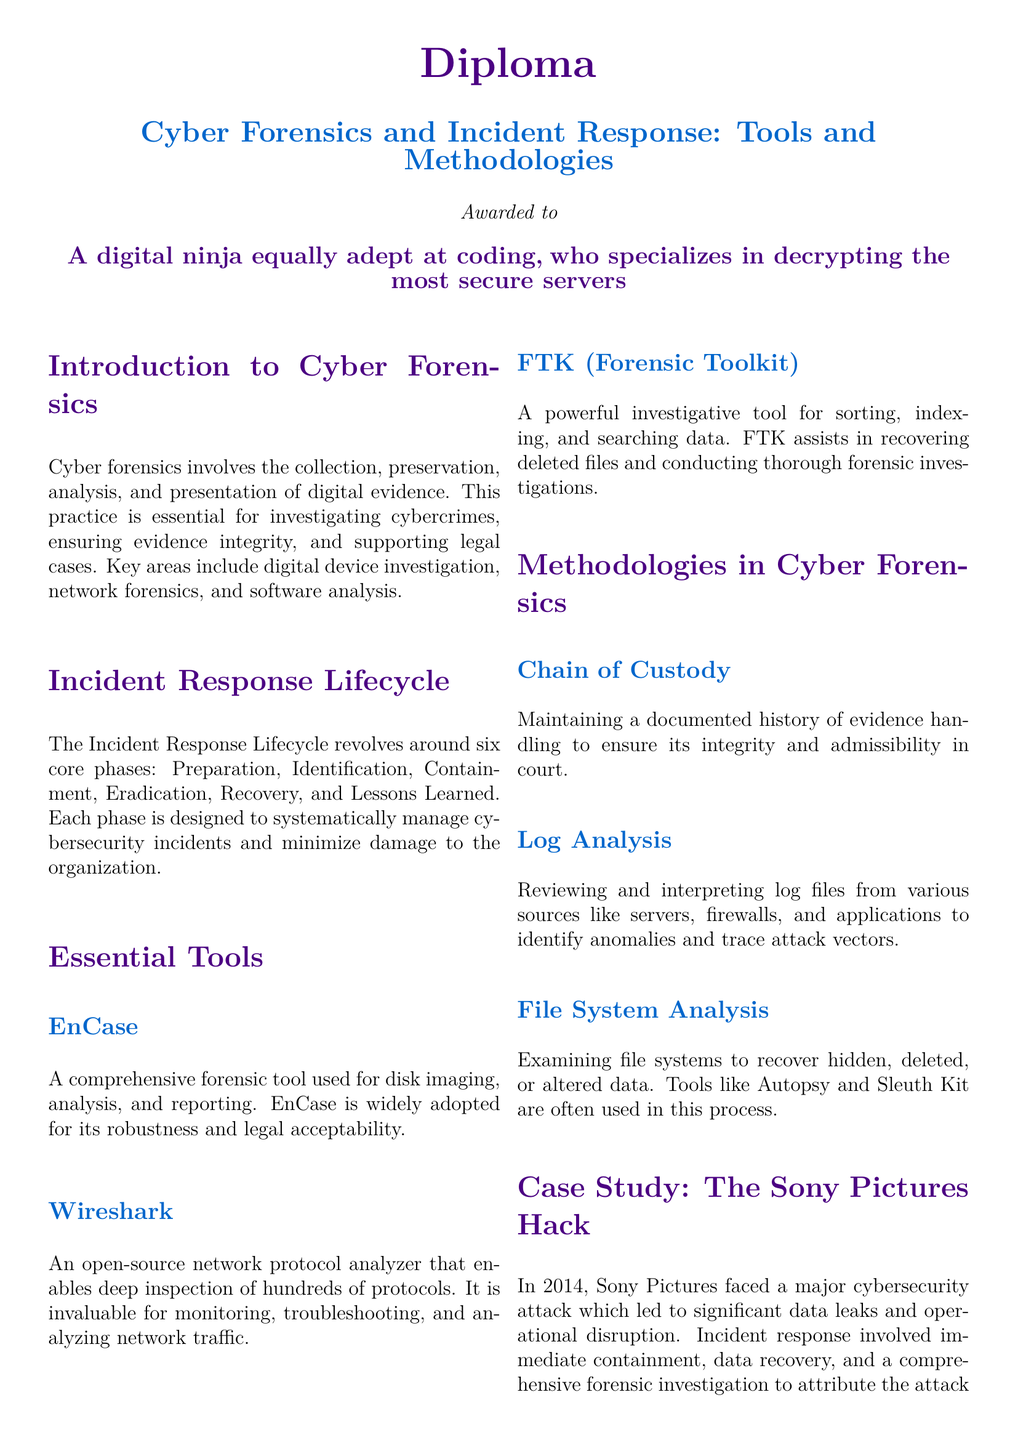What is the title of the diploma? The title of the diploma is mentioned at the top of the document under the main heading section.
Answer: Cyber Forensics and Incident Response: Tools and Methodologies What year did the Sony Pictures hack occur? The specific year of the incident is referenced in the case study section of the document.
Answer: 2014 What is one of the essential tools mentioned for forensic analysis? The document lists specific tools under the essential tools section.
Answer: EnCase How many phases are in the Incident Response Lifecycle? The number of phases is stated in the description of the Incident Response Lifecycle section.
Answer: Six Which methodology is concerned with maintaining evidence integrity? The document outlines a specific methodology that relates to evidence handling.
Answer: Chain of Custody What color is used for the main heading in the title? The color used for the main heading is clearly defined in the document's style settings.
Answer: Cyberpurple What does FTK stand for? The abbreviation FTK is expanded in the essential tools section mentioned in the document.
Answer: Forensic Toolkit What is one key area of cyber forensics? The document specifies key areas involved in cyber forensics at the beginning of the introduction section.
Answer: Digital device investigation What is the primary purpose of cyber forensics? The introduction section outlines the primary aim of cyber forensics.
Answer: Investigating cybercrimes 